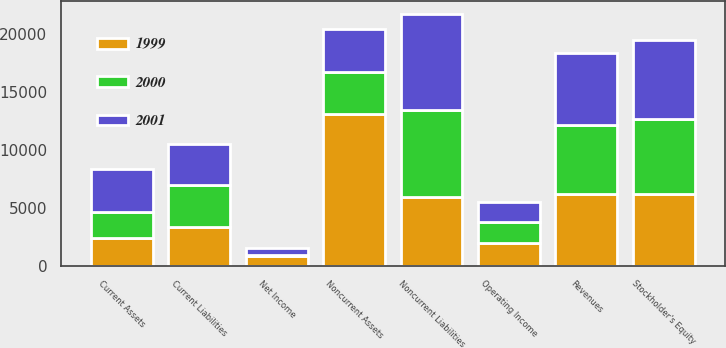<chart> <loc_0><loc_0><loc_500><loc_500><stacked_bar_chart><ecel><fcel>Revenues<fcel>Operating Income<fcel>Net Income<fcel>Current Assets<fcel>Noncurrent Assets<fcel>Current Liabilities<fcel>Noncurrent Liabilities<fcel>Stockholder's Equity<nl><fcel>2001<fcel>6147<fcel>1717<fcel>650<fcel>3700<fcel>3668.5<fcel>3510<fcel>8297<fcel>6836<nl><fcel>1999<fcel>6241<fcel>1989<fcel>859<fcel>2423<fcel>13080<fcel>3370<fcel>5927<fcel>6206<nl><fcel>2000<fcel>5960<fcel>1839<fcel>62<fcel>2259<fcel>3668.5<fcel>3637<fcel>7536<fcel>6445<nl></chart> 